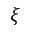<formula> <loc_0><loc_0><loc_500><loc_500>\xi</formula> 